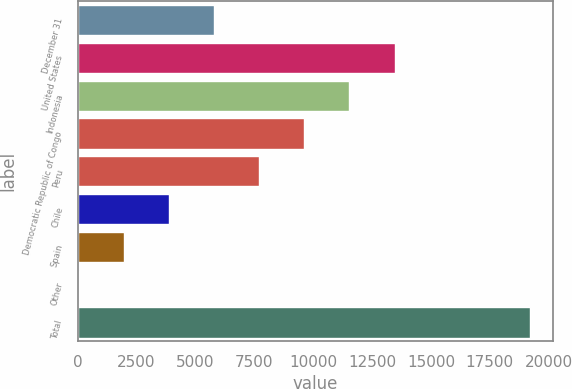Convert chart. <chart><loc_0><loc_0><loc_500><loc_500><bar_chart><fcel>December 31<fcel>United States<fcel>Indonesia<fcel>Democratic Republic of Congo<fcel>Peru<fcel>Chile<fcel>Spain<fcel>Other<fcel>Total<nl><fcel>5795.1<fcel>13457.9<fcel>11542.2<fcel>9626.5<fcel>7710.8<fcel>3879.4<fcel>1963.7<fcel>48<fcel>19205<nl></chart> 